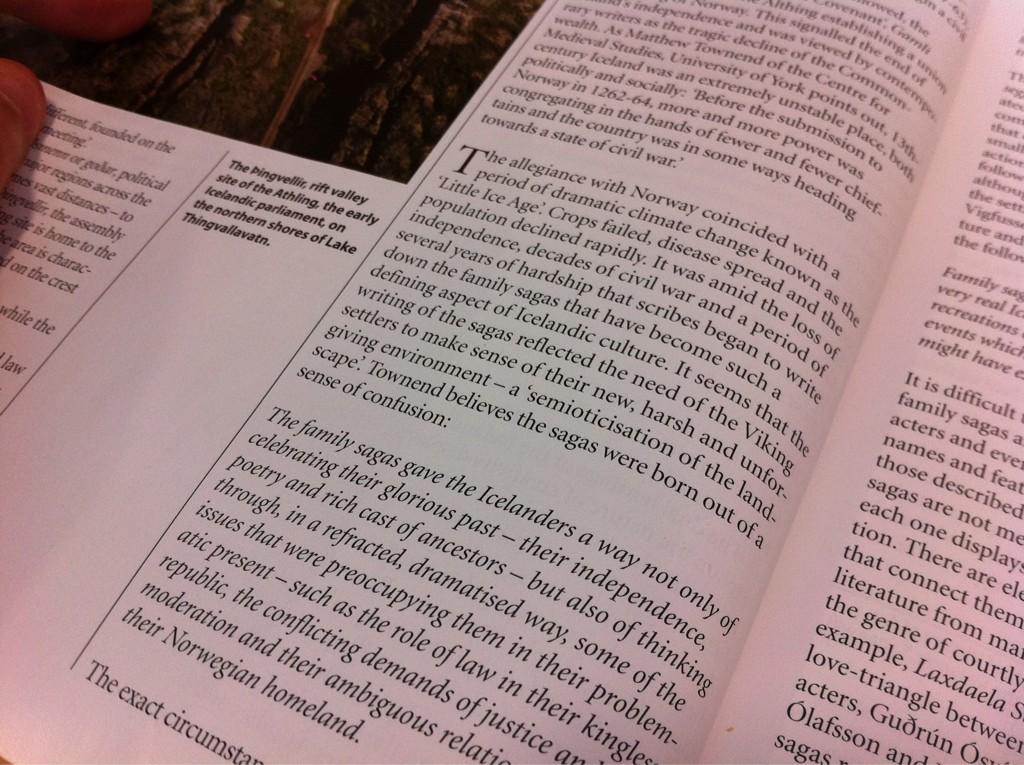What is the first word in the middle paragraph?
Offer a very short reply. The. What is the big letter on the page?
Provide a succinct answer. T. 